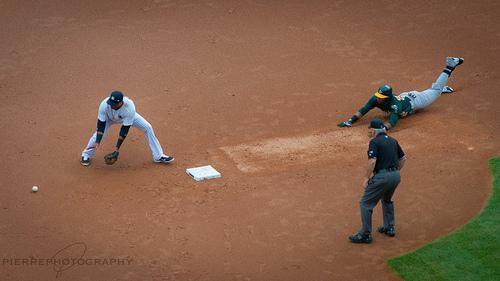Identify the action performed by the baseball player wearing a white uniform. The baseball player with a white uniform is sliding into second base. Assess the overall sentiment of the image considering the players’ actions. The image depicts a tense and action-packed moment during a baseball game, with players striving to outperform each other. What type of clothing is worn by the umpire and what colors are they? The umpire is wearing a black shirt and gray pants. Count the baseball players and umpires mentioned in the given image description. There are 6 baseball players and 5 umpires mentioned. Enumerate the colors of the baseball gloves and the handedness of each mentioned in the image description. Right handed leather baseball glove is brown and black, while the other leather mitt is black and brown. What is the primary color of the baseball infield? The baseball infield is primarily green due to the grass. Analyze the interaction between the baseball player sliding into the base and the other catching the ball. The baseball player sliding into the base is attempting to safely reach second base, while the other player is trying to catch the ball to potentially make an out. Explain how the positions of the umpire and the baseball players are related. The second base umpire is watching the baseball players interact, as one player slides into the base and the other is ready to catch the ball. Describe the appearance of the baseball on the ground. The baseball on the ground is white with black stitches. Describe the position of the baseball player with a leather glove. The baseball player with a leather glove is ready to catch a baseball. Locate the white square baseball plate. The white square baseball plate is at X:179 Y:152 Width:61 Height:61 Identify the positions of "foot tracks in dirt" and "slide mark from baseball sliders before." Foot tracks in dirt: X:249 Y:210 Width:57 Height:57, Slide mark from baseball sliders before: X:220 Y:127 Width:139 Height:139 Can you see a football player in the brown ground area? The image is from a baseball game; there is no mention of a football player nor any related element to football in the image. Explain the interaction between the baseball player and the umpire. The baseball player is sliding into the base while the umpire is watching closely. What is the sentiment of the scene in the image? Neutral or competitive What type of stance does the referee have at position X:364 Y:130? Super ref's stance What type of glove is on the baseball player at X:100 Y:148? Leather mitt Distinguish between the green grass and the dirt on the baseball field. Green grass is at X:382 Y:155 Width:116 Height:116 and dirt at X:0 Y:0 Width:497 Height:497 What text or logo is visible in the image? Name and logo of the photographer who took this photo at X:0 Y:239 Width:135 Height:135 Describe the color and type of the baseball at X:27 Y:182. Black and white baseball Does the second base umpire have a green hat on? There are captions that mention an umpire with a black shirt and gray pants, but there is no mention of an umpire wearing a green hat. What is the action of the baseball player at position X:332 Y:49? Sliding into second base How is the overall quality of the image? The image is of good quality. Is there a pink tennis shoe on the baseball infield green grass? There might be a mention of a white tennis shoe, but there isn't any information about a pink tennis shoe in the image. Which base is at position X:180 Y:163? Third base Does the baseball player sliding into second base wear a helmet? Yes, the baseball player sliding into second base wears a helmet. Does the baseball player have a yellow and blue glove on? There are mentions of a baseball player with a leather glove and a baseball mitt, but no mention of a yellow and blue glove in the image. Which character from the following list is wearing a dark blue baseball cap: a) baseball player b) umpire c) photographer? a) baseball player Is there a dog running across the baseball field? None of the given captions mention any animals, particularly a dog, in the image of the baseball game. Is the baseball player with a red uniform sliding into second base? The image might have a baseball player sliding into second base, but nothing specifies that the player has a red uniform.  How many baseball players are there in the image? Two baseball players What is the color of the batting helmet on the man at X:372 Y:84? Green and yellow Identify any anomalies or unusual objects in the image. There are no apparent anomalies or unusual objects in the image. What type of shoes does the person at position X:442 Y:52 wear? Hightop cleats What protective gear is worn by the baseball player at position X:72 Y:85? A dark blue baseball cap 